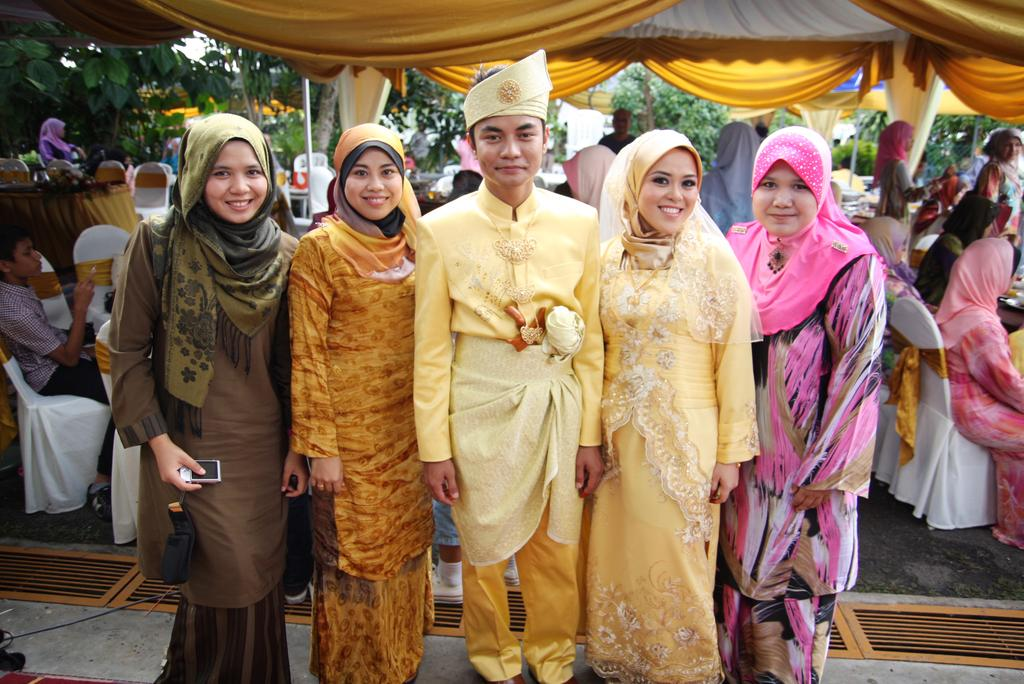What are the people in the image doing? There is a group of people standing and smiling in the image. Can you describe the other group of people in the image? There is another group of people sitting on chairs under tents in the image. What type of natural elements can be seen in the image? There are trees visible in the image. What type of furniture is present in the image? Chairs and tables are present in the image. What type of cord is being used to hold the locket in the image? There is no locket or cord present in the image. 